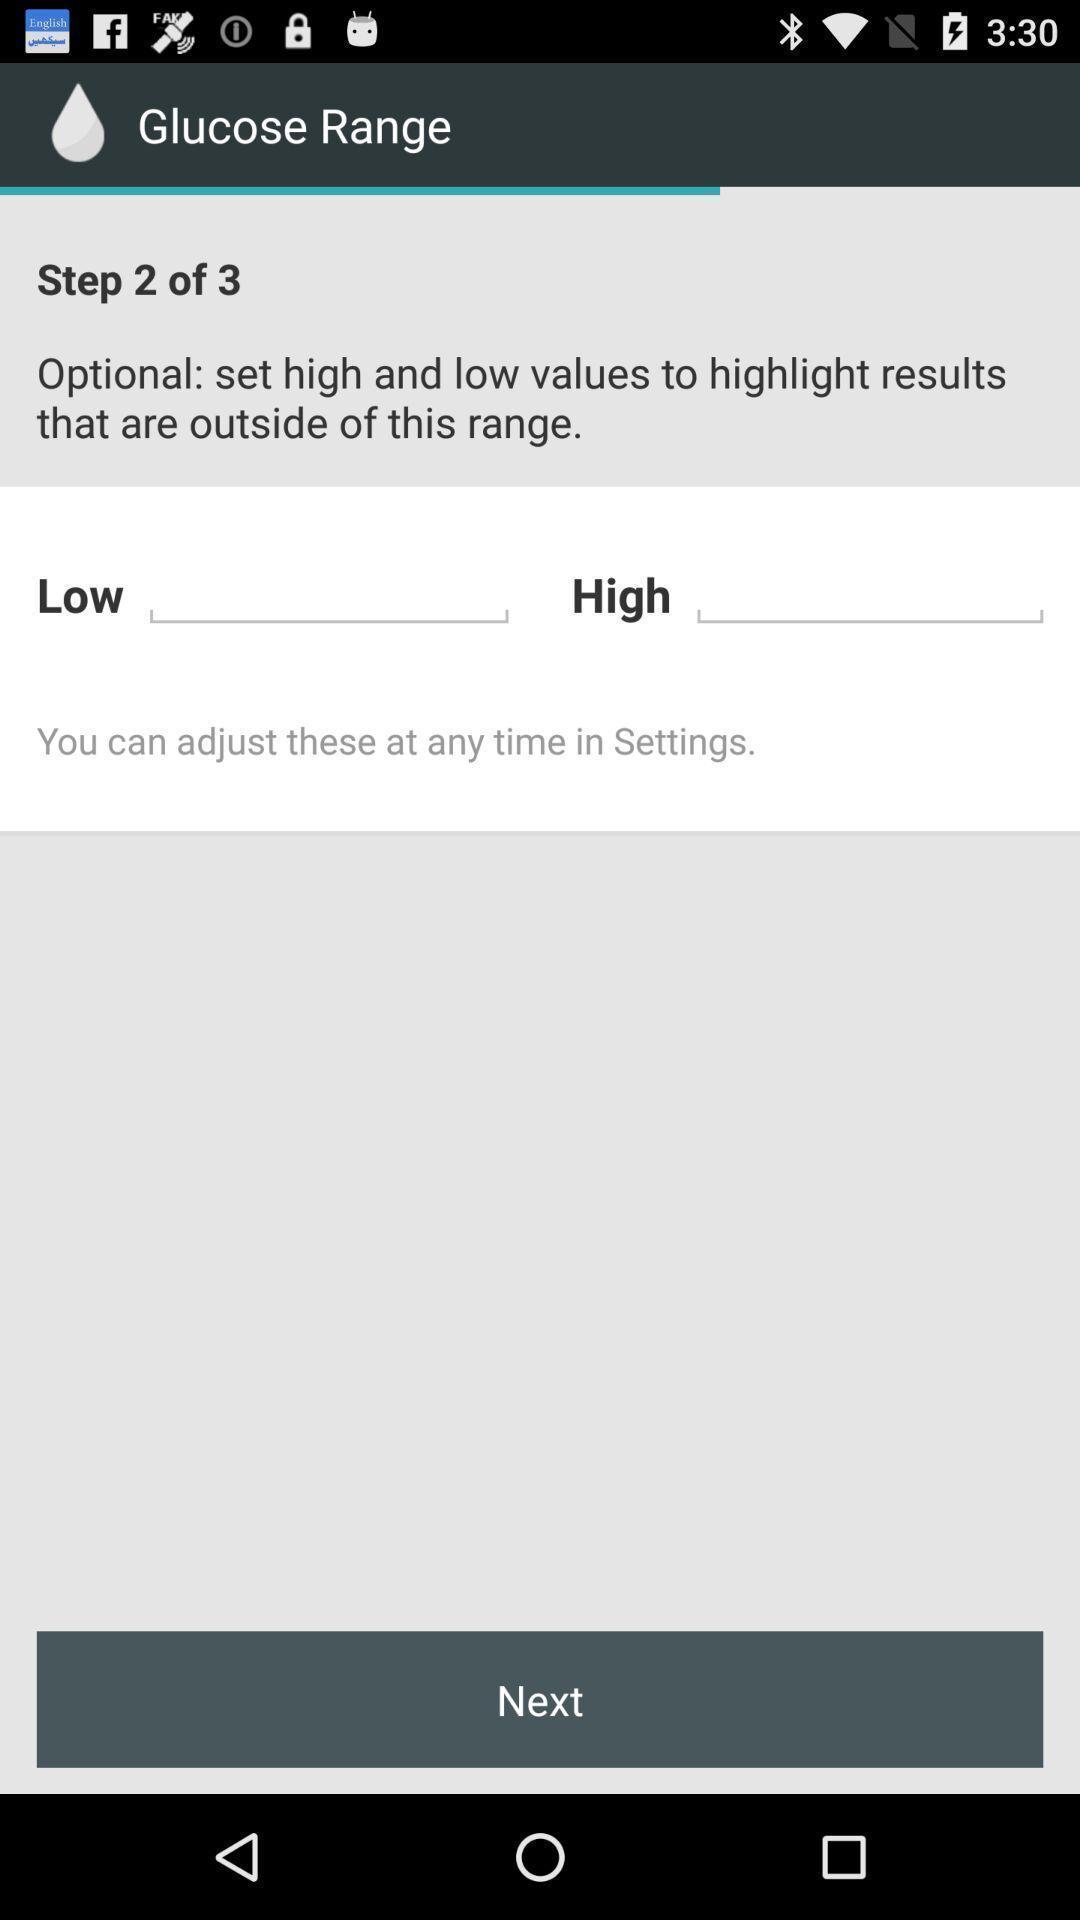Provide a detailed account of this screenshot. Page showing next option. 